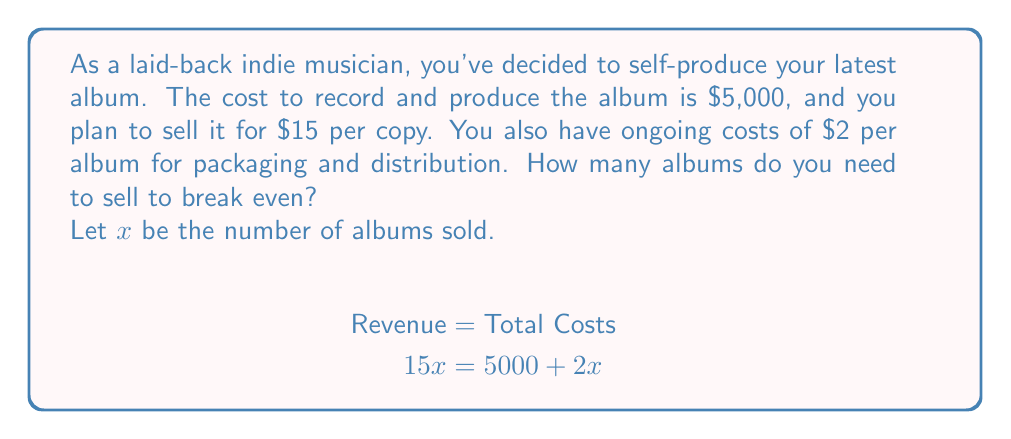Teach me how to tackle this problem. To find the break-even point, we need to determine the number of albums sold where the revenue equals the total costs.

1. Set up the equation:
   Revenue = Fixed Costs + Variable Costs
   $15x = 5000 + 2x$

2. Isolate the variable terms on one side:
   $15x - 2x = 5000$
   $13x = 5000$

3. Solve for x:
   $$x = \frac{5000}{13} \approx 384.62$$

4. Since we can't sell a fraction of an album, we round up to the nearest whole number.

The break-even point is 385 albums. Let's verify:

Revenue: $15 \times 385 = 5775$
Total Costs: $5000 + (2 \times 385) = 5770$

At 385 albums, revenue slightly exceeds costs, confirming the break-even point.
Answer: You need to sell 385 albums to break even. 